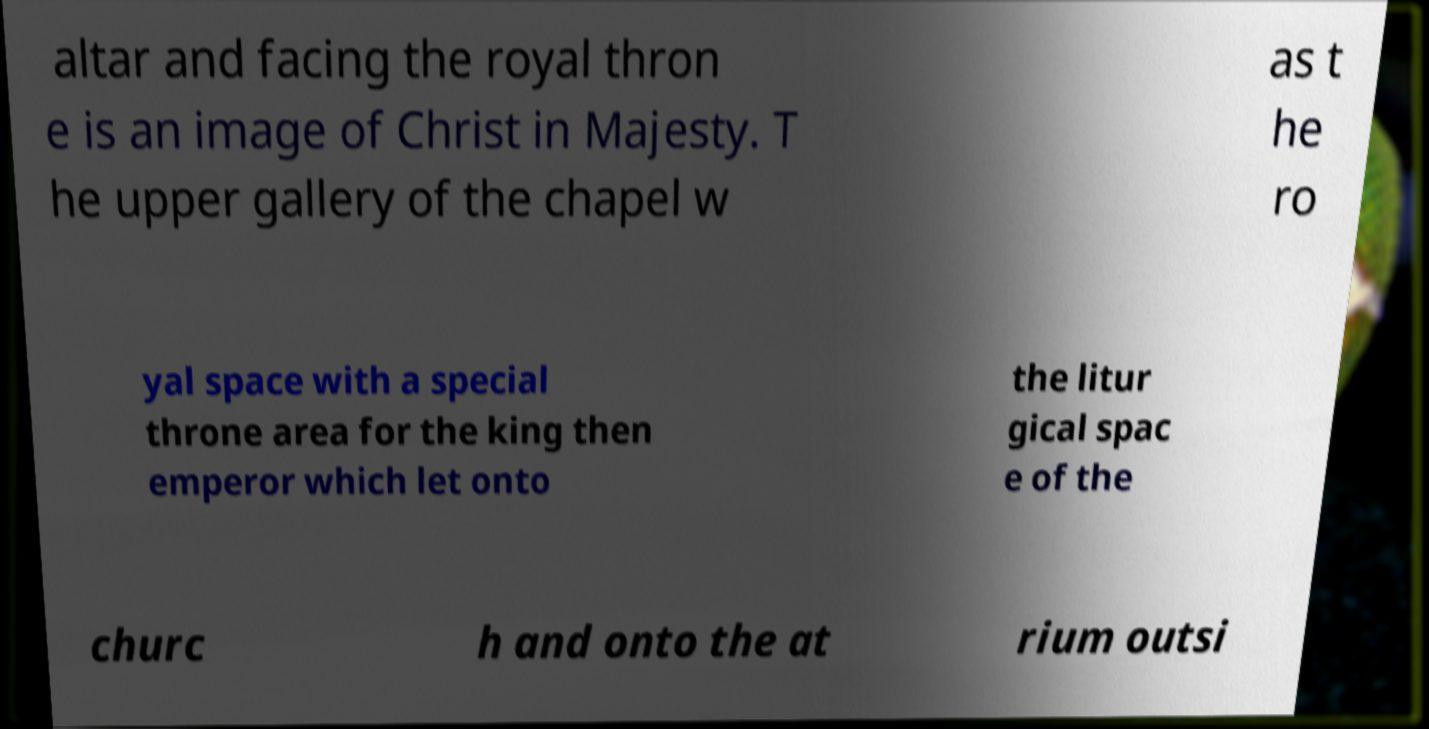Please identify and transcribe the text found in this image. altar and facing the royal thron e is an image of Christ in Majesty. T he upper gallery of the chapel w as t he ro yal space with a special throne area for the king then emperor which let onto the litur gical spac e of the churc h and onto the at rium outsi 